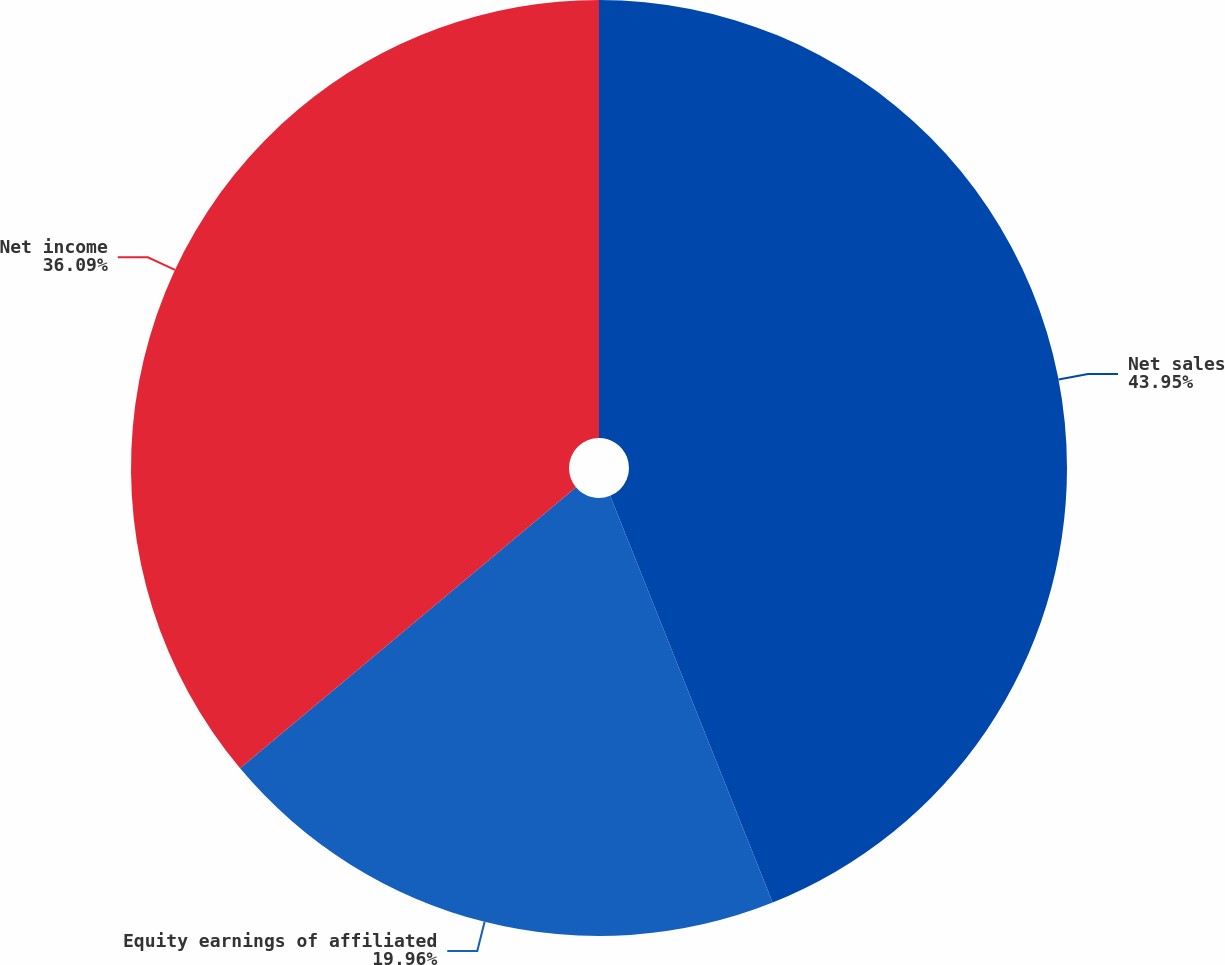Convert chart. <chart><loc_0><loc_0><loc_500><loc_500><pie_chart><fcel>Net sales<fcel>Equity earnings of affiliated<fcel>Net income<nl><fcel>43.95%<fcel>19.96%<fcel>36.09%<nl></chart> 